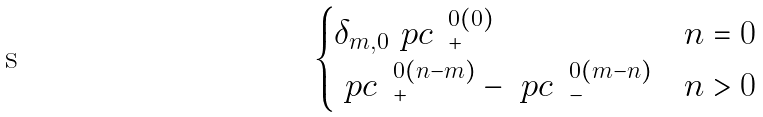<formula> <loc_0><loc_0><loc_500><loc_500>\begin{cases} \delta _ { m , 0 } \ p c \ \, ^ { 0 ( 0 ) } _ { + } & n = 0 \\ \ p c \ \, ^ { 0 ( n - m ) } _ { + } - \ p c \ \, ^ { 0 ( m - n ) } _ { - } & n > 0 \end{cases}</formula> 